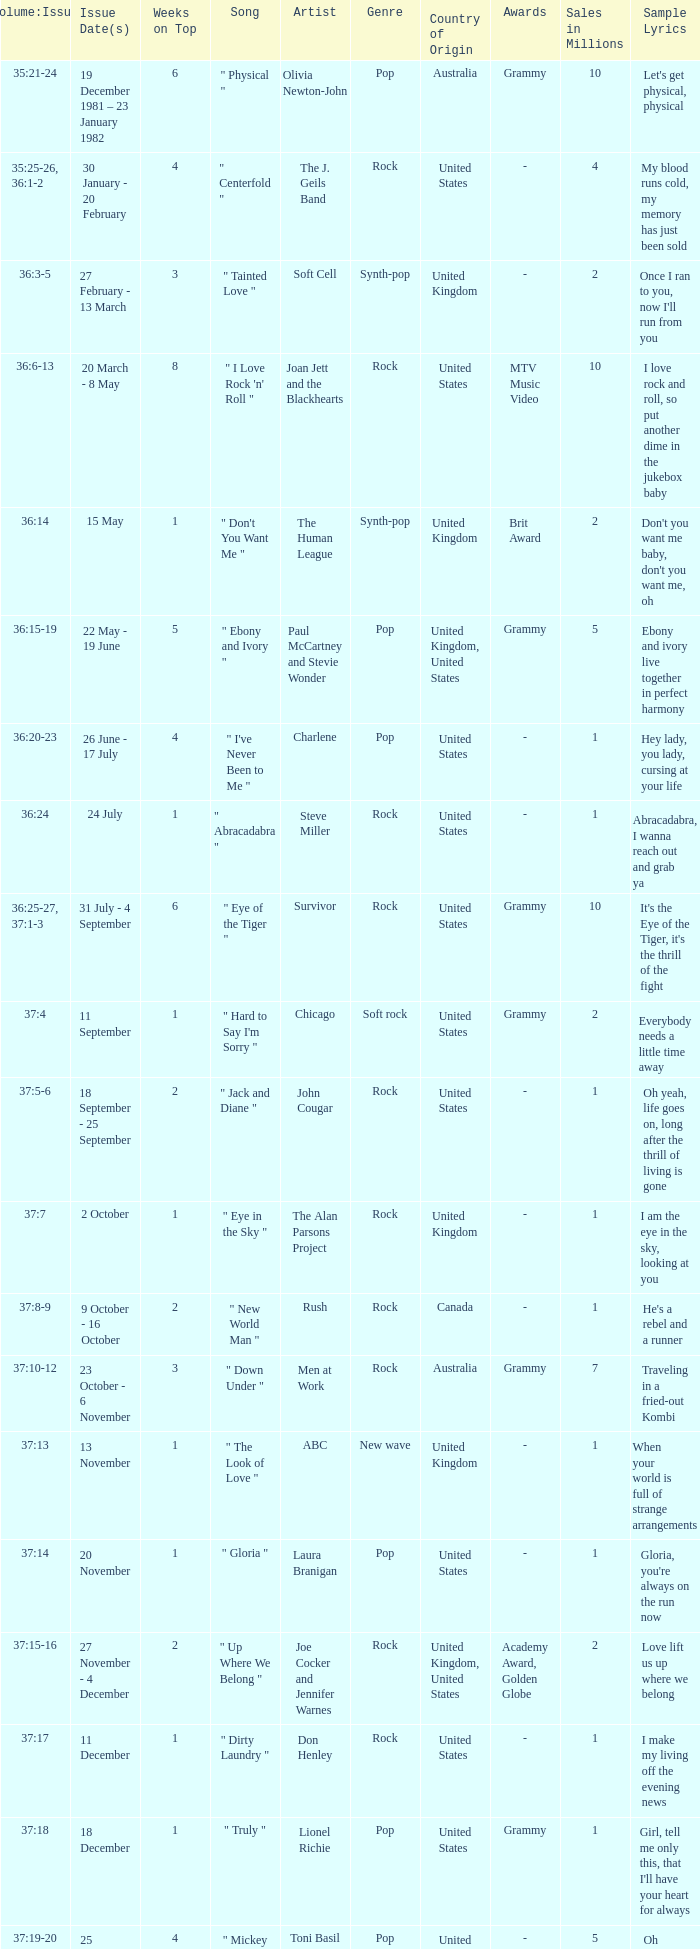Which Issue Date(s) has Weeks on Top larger than 3, and a Volume: Issue of 35:25-26, 36:1-2? 30 January - 20 February. 